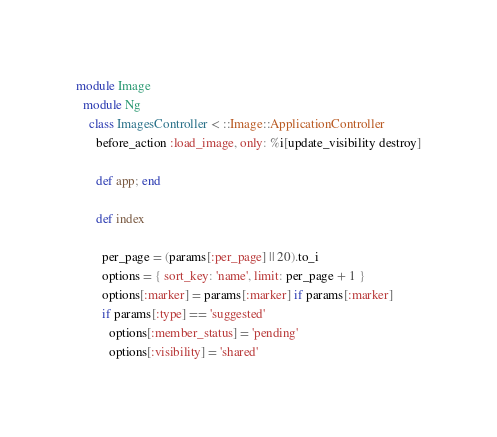Convert code to text. <code><loc_0><loc_0><loc_500><loc_500><_Ruby_>module Image
  module Ng
    class ImagesController < ::Image::ApplicationController
      before_action :load_image, only: %i[update_visibility destroy]

      def app; end

      def index

        per_page = (params[:per_page] || 20).to_i
        options = { sort_key: 'name', limit: per_page + 1 }
        options[:marker] = params[:marker] if params[:marker]
        if params[:type] == 'suggested'
          options[:member_status] = 'pending'
          options[:visibility] = 'shared'</code> 